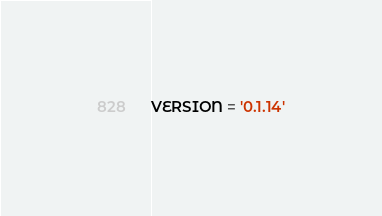Convert code to text. <code><loc_0><loc_0><loc_500><loc_500><_Python_>VERSION = '0.1.14'</code> 